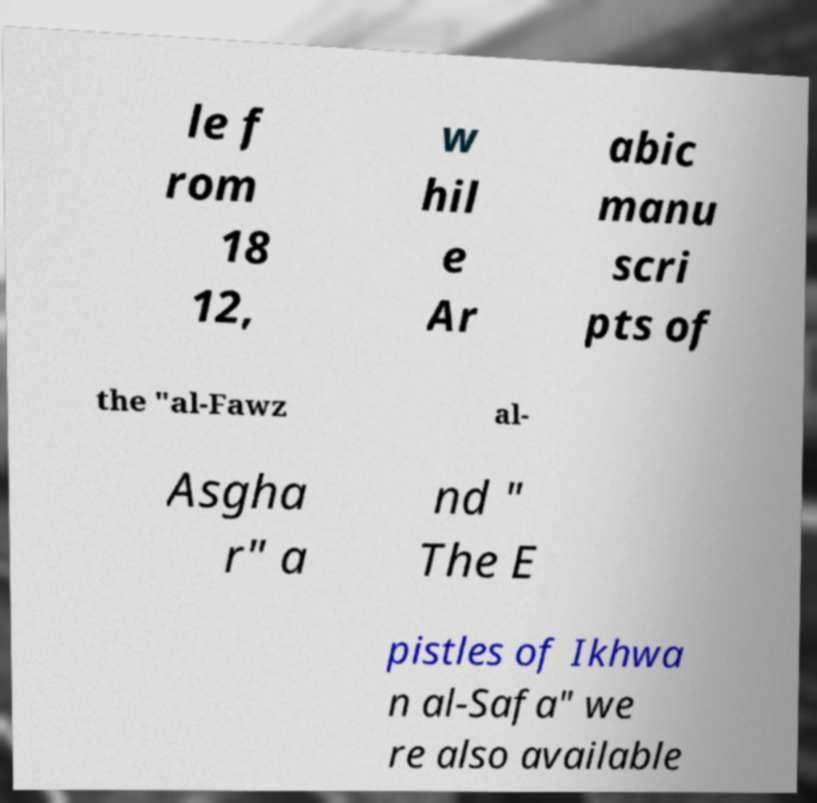For documentation purposes, I need the text within this image transcribed. Could you provide that? le f rom 18 12, w hil e Ar abic manu scri pts of the "al-Fawz al- Asgha r" a nd " The E pistles of Ikhwa n al-Safa" we re also available 